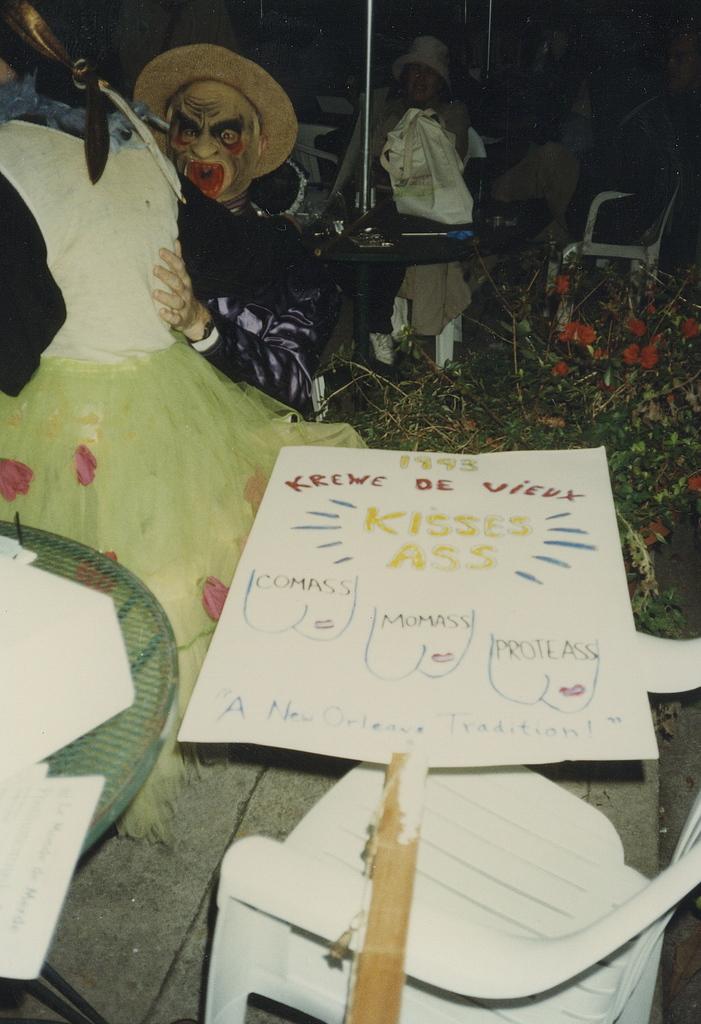What do they kiss?
Ensure brevity in your answer.  Ass. 